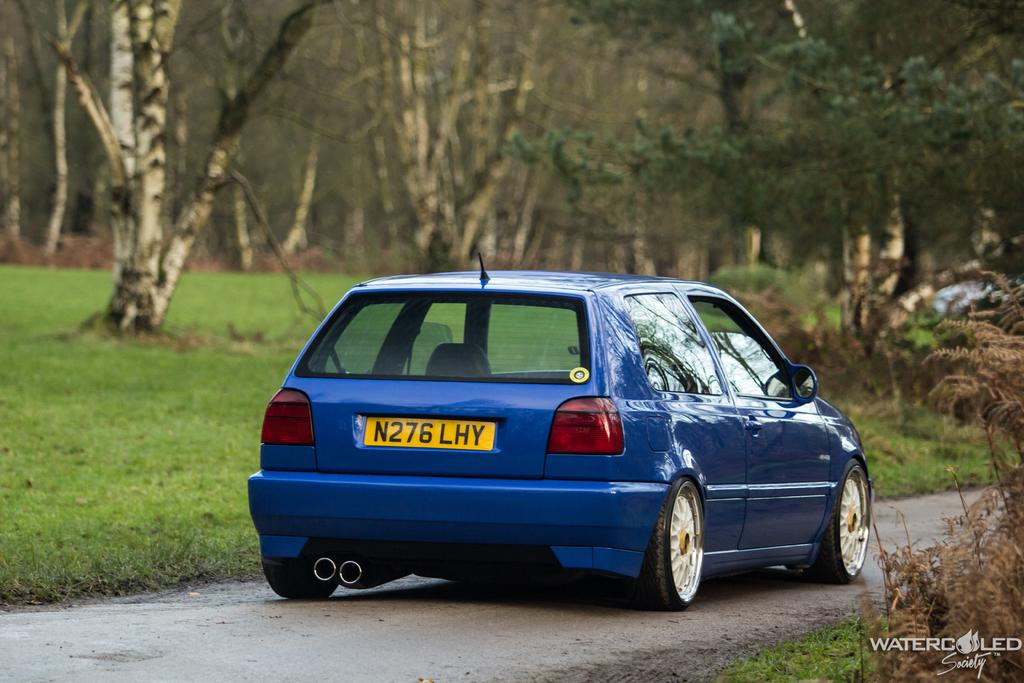What is on the road in the image? There is a vehicle on the road in the image. What type of vegetation can be seen in the image? There is grass and trees visible in the image. Can you describe the condition of the plant in the image? There is a dry plant in the image. Is there any text or marking in the image? Yes, there is a watermark in the bottom right corner of the image. What type of card is being held by the minute in the image? There is no minute or card present in the image; it features a vehicle on the road, grass, trees, a dry plant, and a watermark. 